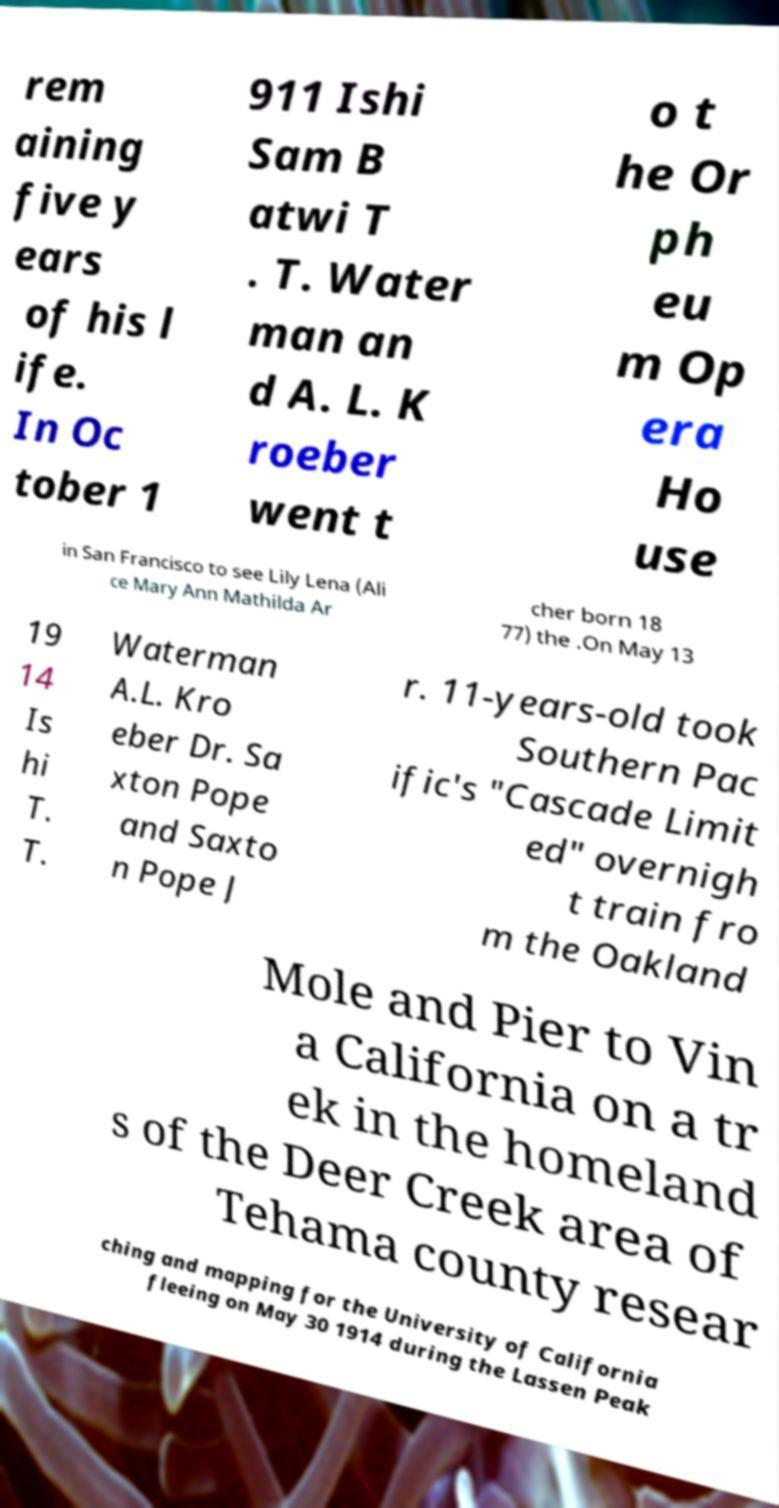Can you accurately transcribe the text from the provided image for me? rem aining five y ears of his l ife. In Oc tober 1 911 Ishi Sam B atwi T . T. Water man an d A. L. K roeber went t o t he Or ph eu m Op era Ho use in San Francisco to see Lily Lena (Ali ce Mary Ann Mathilda Ar cher born 18 77) the .On May 13 19 14 Is hi T. T. Waterman A.L. Kro eber Dr. Sa xton Pope and Saxto n Pope J r. 11-years-old took Southern Pac ific's "Cascade Limit ed" overnigh t train fro m the Oakland Mole and Pier to Vin a California on a tr ek in the homeland s of the Deer Creek area of Tehama county resear ching and mapping for the University of California fleeing on May 30 1914 during the Lassen Peak 